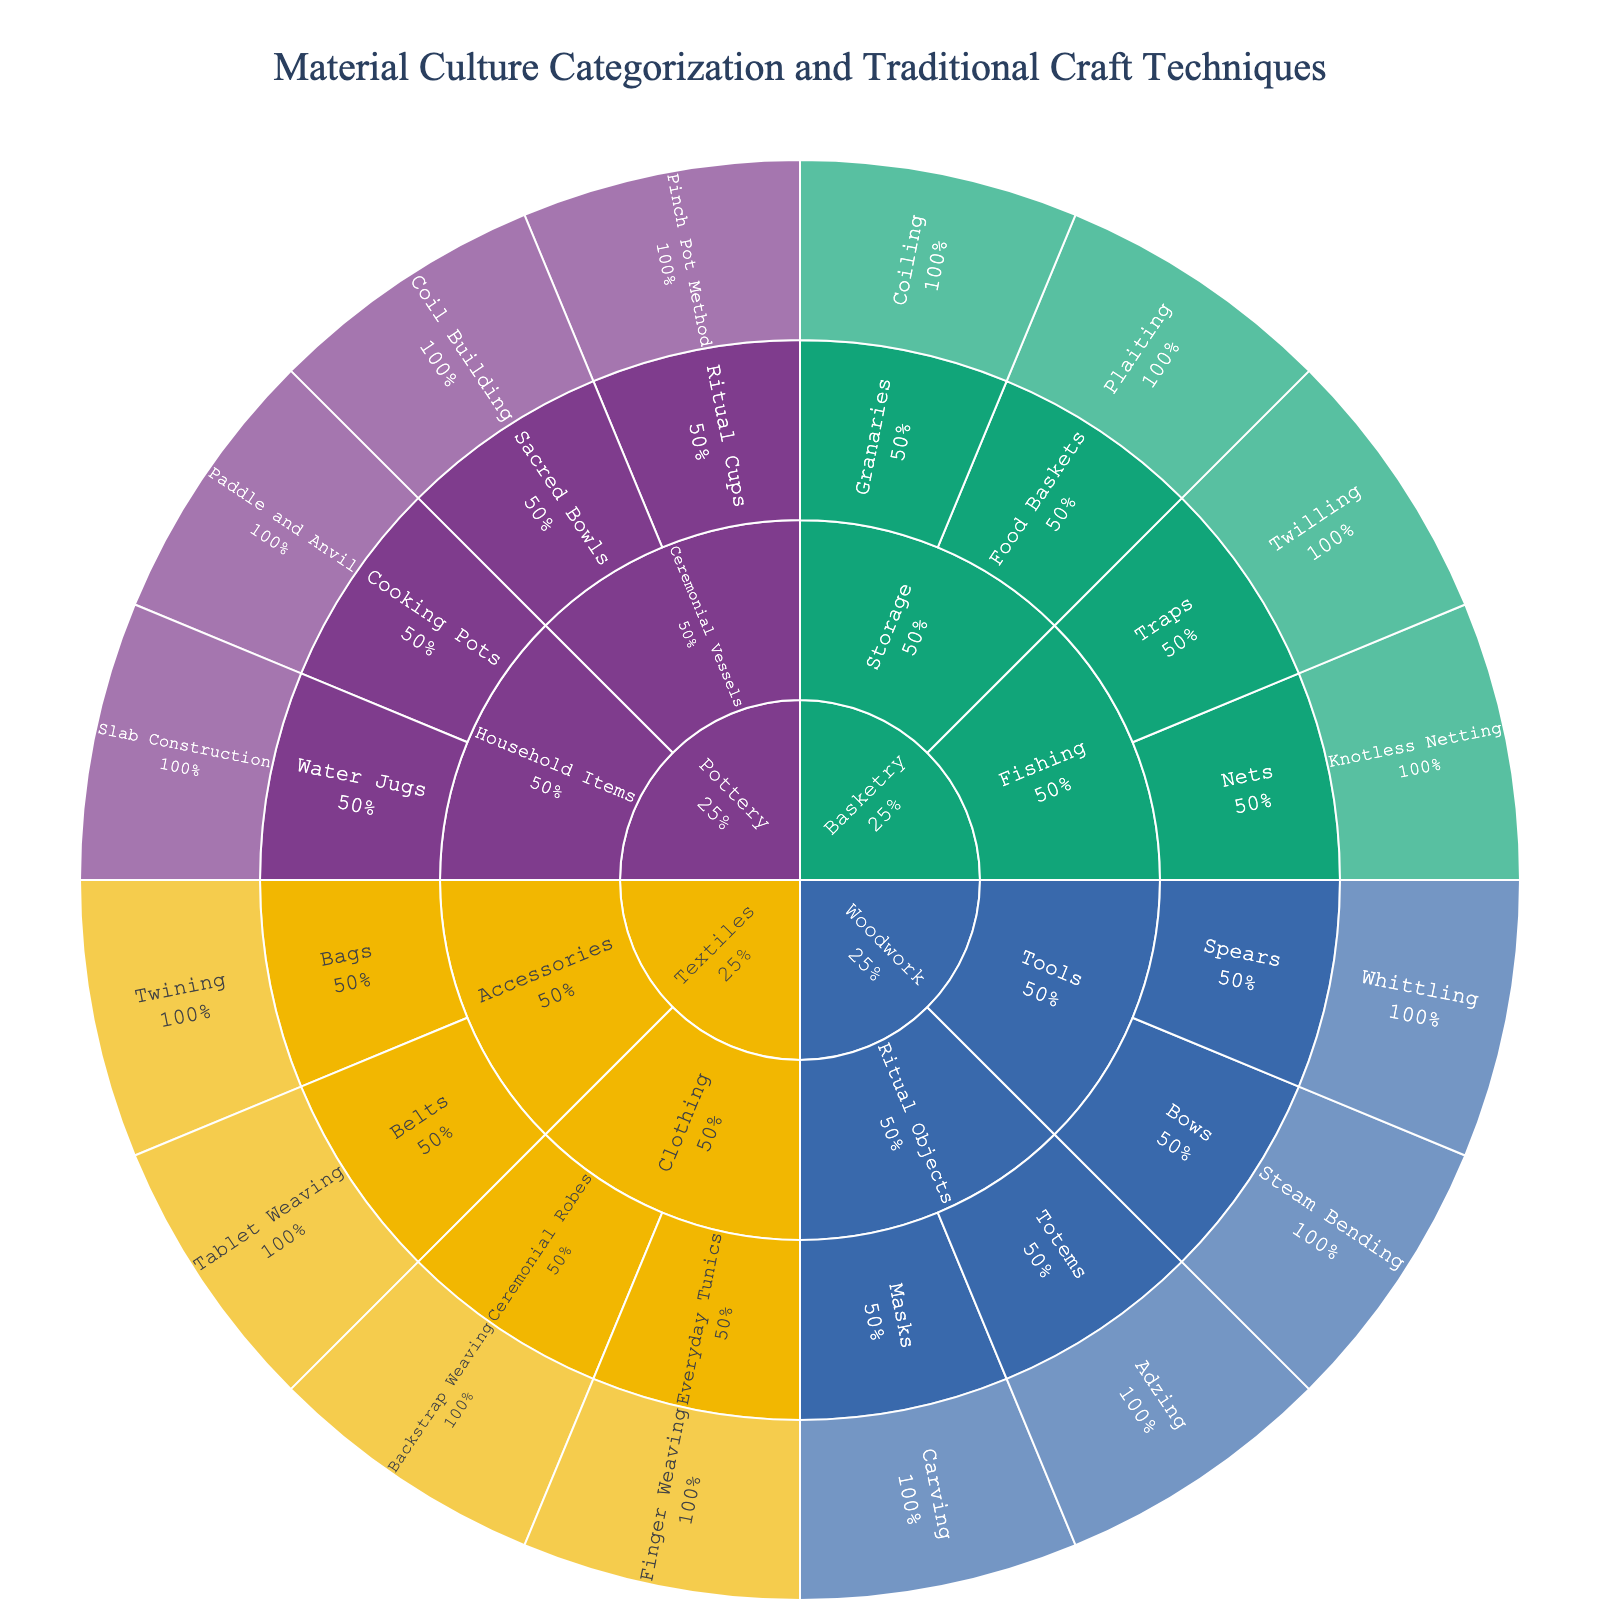How many main categories are displayed in the sunburst plot? The sunburst plot's first level corresponds to the main categories. By observing, we can count the number of segments directly connected to the center.
Answer: 4 What technique is used for creating Sacred Bowls in Pottery? To find this, we have to navigate from the main category Pottery, then go to the subcategory Ceremonial Vessels, and finally to the item Sacred Bowls. The technique will be displayed there.
Answer: Coil Building How many different items are listed under the Woodwork category? Under Woodwork, we need to count all the segments branching out from its subcategories (Tools and Ritual Objects).
Answer: 4 Which category contains the item Traps, and what technique is used to create it? Start by identifying the item Traps in the plot, then trace the hierarchy back to the subcategory (Fishing) and main category (Basketry). The technique used will be directly linked to the item.
Answer: Basketry, Twilling Compare the number of items under the categories Pottery and Textiles. Which has more items? Count the items by navigating through the subcategories of Pottery and Textiles. Compare the totals.
Answer: Pottery Is the technique used for Ritual Cups in the Pottery category more complex than the technique used for Granaries in the Basketry category? This is subjective and requires knowledge beyond the visual plot to understand the complexity. However, one can compare the hierarchical level and presumed craft complexity. Visually, Ritual Cups (Pinch Pot Method) and Granaries (Coiling) need to be compared.
Answer: Subjective, cannot be determined from the plot alone What percentage of the total items does the Fishing subcategory in Basketry represent? Calculate the number of items in Fishing as a proportion of the total number of items, assuming each item is equally significant.
Answer: 2/16 or 12.5% Which technique is used for creating Bows in the Woodwork category? Navigate through Woodwork, then Tools, and finally to Bows. The associated technique will be listed there.
Answer: Steam Bending How do the techniques used in creating items under the Clothing subcategory in Textiles compare in diversity to those used under Household Items in Pottery? List the techniques for Clothing (Backstrap Weaving, Finger Weaving) and for Household Items (Paddle and Anvil, Slab Construction) and compare the variety.
Answer: Both subcategories use 2 different techniques What is the most frequently used technique across all items? Identify and count occurrences of each technique by navigating through all the categories and subcategories. Find the technique with the highest count.
Answer: Twining (appears twice) 